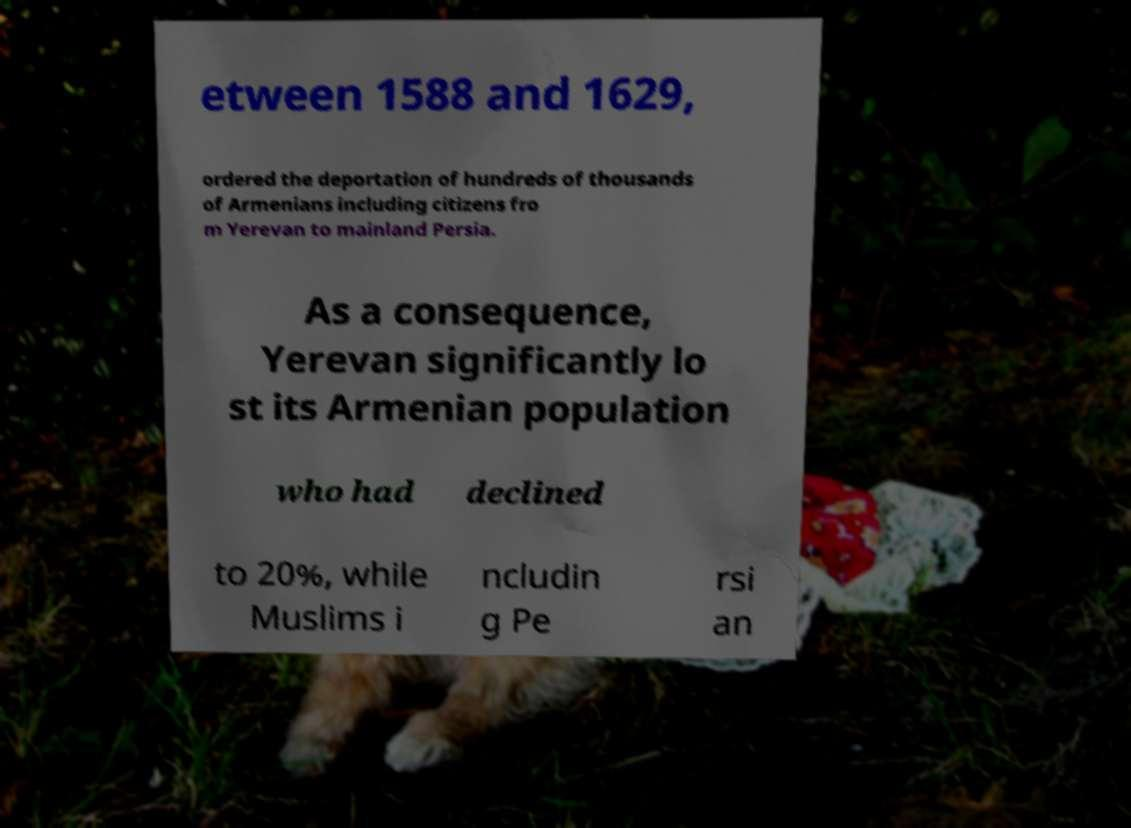Please identify and transcribe the text found in this image. etween 1588 and 1629, ordered the deportation of hundreds of thousands of Armenians including citizens fro m Yerevan to mainland Persia. As a consequence, Yerevan significantly lo st its Armenian population who had declined to 20%, while Muslims i ncludin g Pe rsi an 